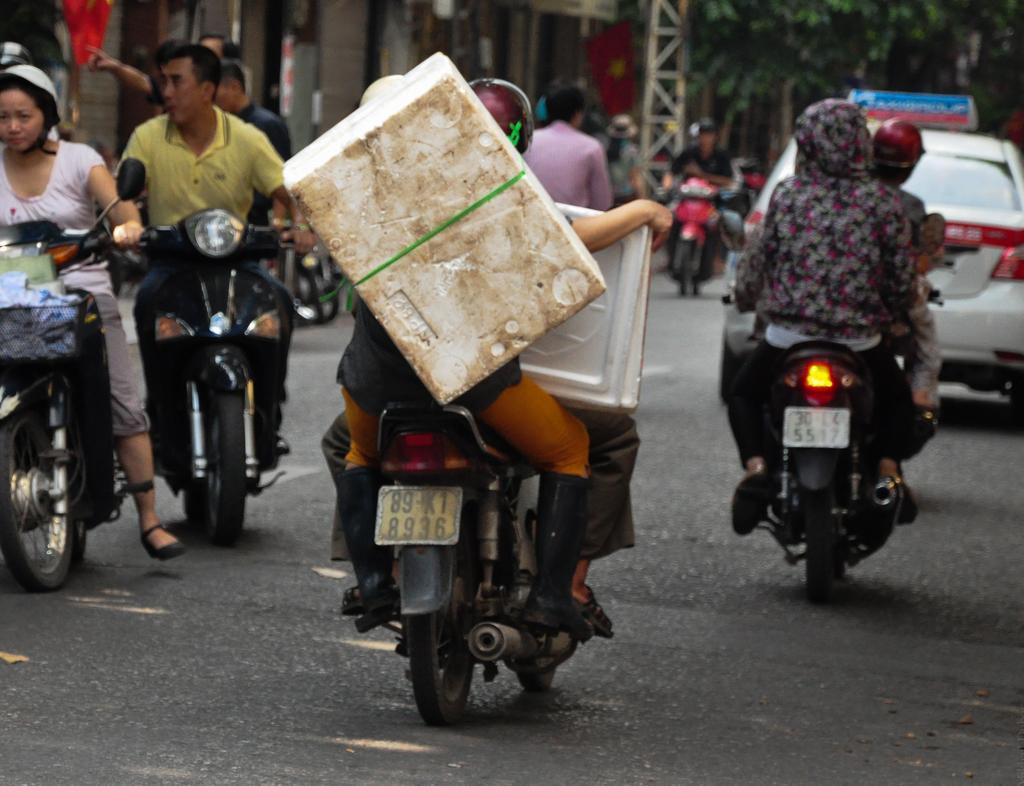Could you give a brief overview of what you see in this image? Completely an outdoor picture. People are sitting on a motorbike and riding. A white car is on road. Far there are trees and flag. 